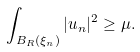<formula> <loc_0><loc_0><loc_500><loc_500>\int _ { B _ { R } ( \xi _ { n } ) } | u _ { n } | ^ { 2 } \geq \mu .</formula> 